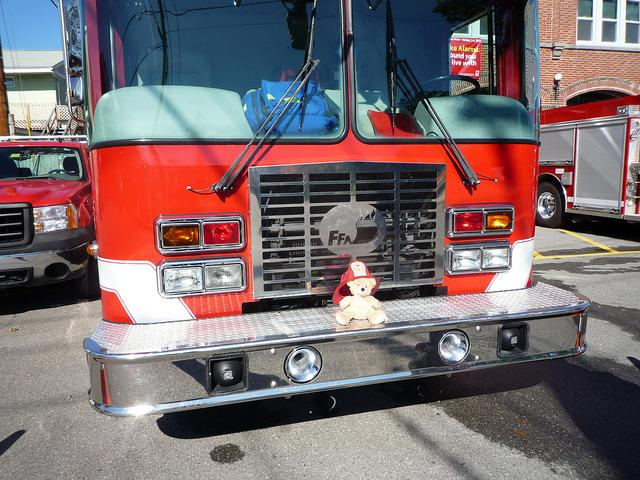How many types of fire engines are available? two 